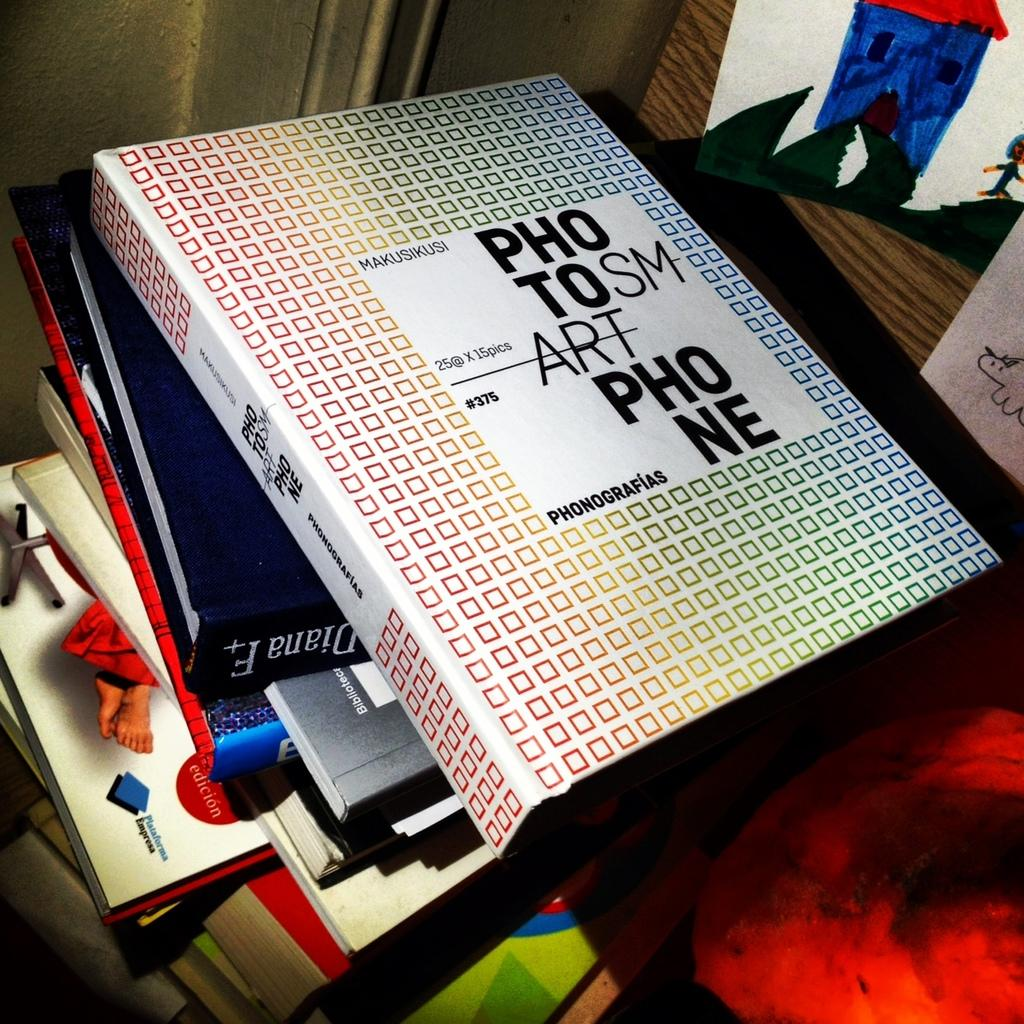<image>
Write a terse but informative summary of the picture. A book cover has a bunch of squares and the number 375 on the cover. 